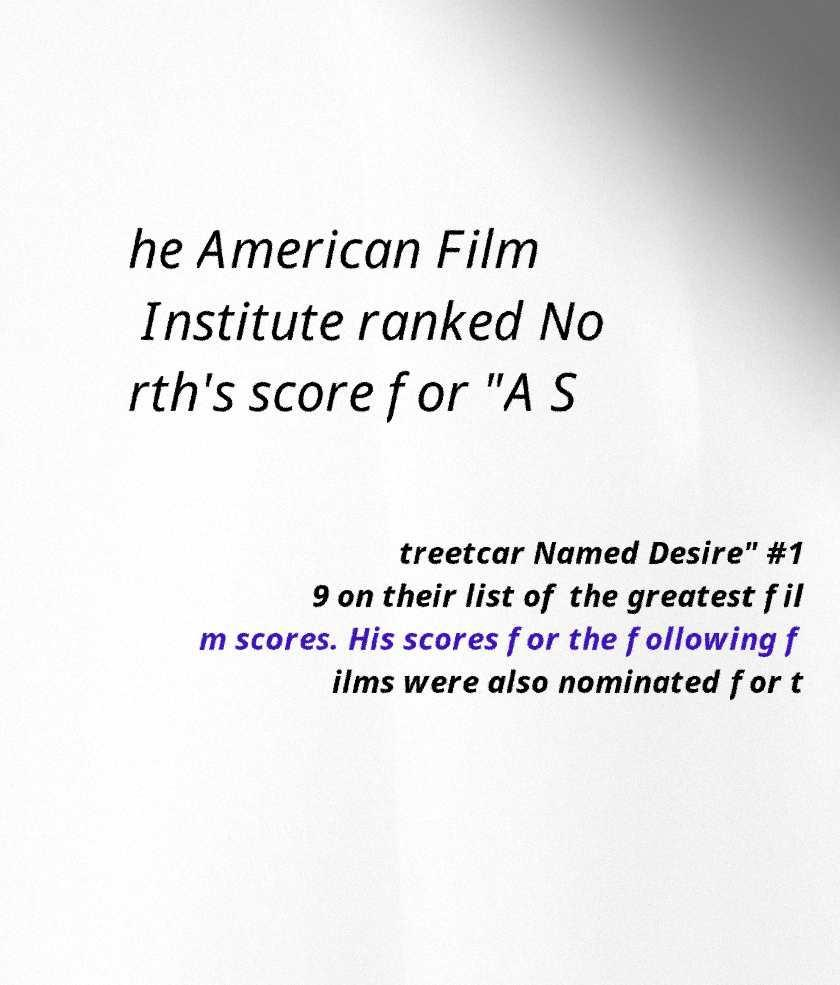Can you read and provide the text displayed in the image?This photo seems to have some interesting text. Can you extract and type it out for me? he American Film Institute ranked No rth's score for "A S treetcar Named Desire" #1 9 on their list of the greatest fil m scores. His scores for the following f ilms were also nominated for t 